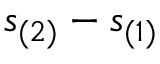Convert formula to latex. <formula><loc_0><loc_0><loc_500><loc_500>s _ { ( 2 ) } - s _ { ( 1 ) }</formula> 